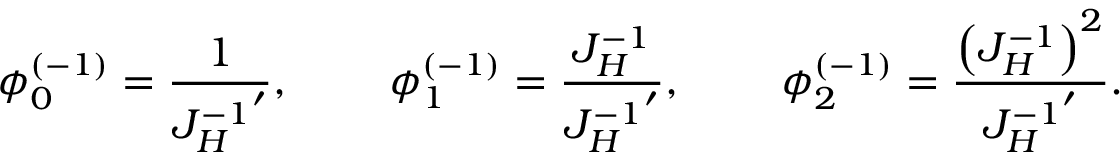Convert formula to latex. <formula><loc_0><loc_0><loc_500><loc_500>\phi _ { 0 } ^ { ( - 1 ) } = { \frac { 1 } { { J _ { H } ^ { - 1 } } ^ { \prime } } } , \quad \, \phi _ { 1 } ^ { ( - 1 ) } = { \frac { J _ { H } ^ { - 1 } } { { J _ { H } ^ { - 1 } } ^ { \prime } } } , \quad \, \phi _ { 2 } ^ { ( - 1 ) } = { \frac { \left ( J _ { H } ^ { - 1 } \right ) ^ { 2 } } { { J _ { H } ^ { - 1 } } ^ { \prime } } } .</formula> 